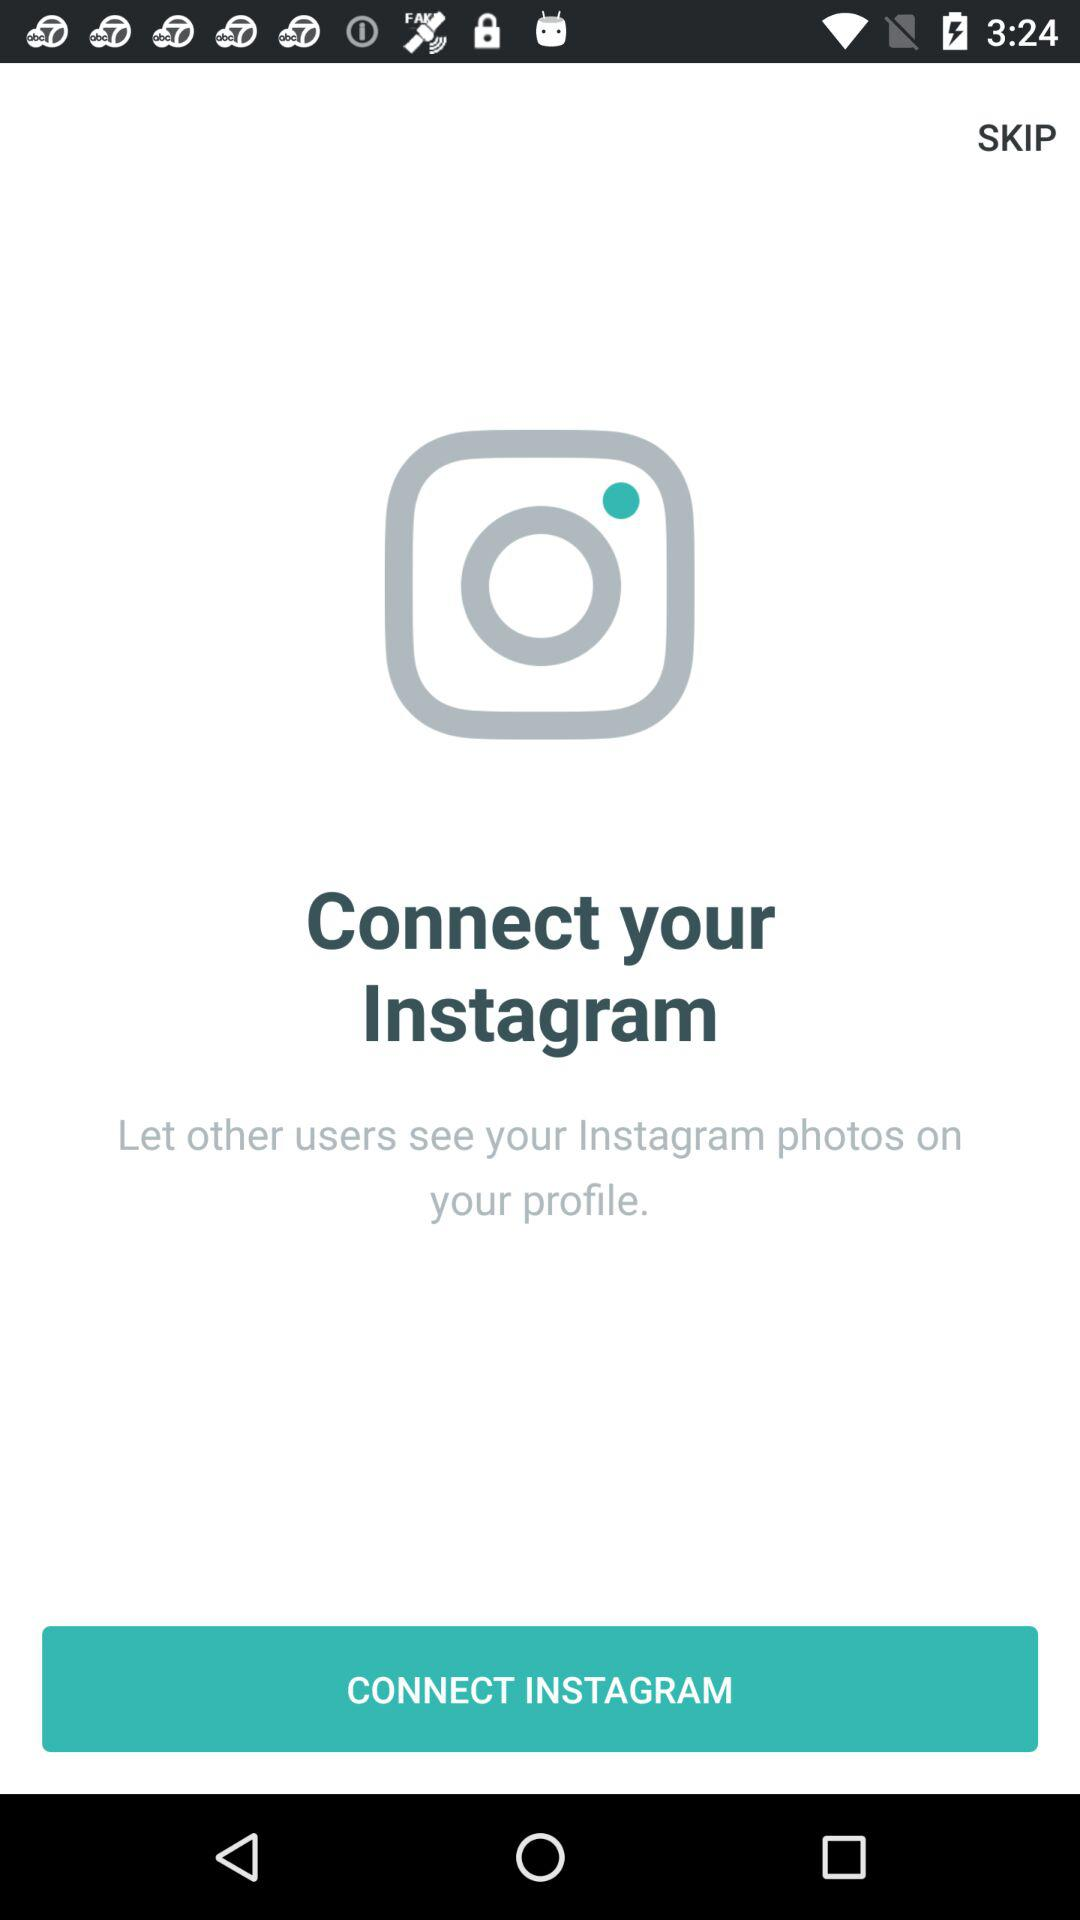What is the name of the application? The name of the application is "Instagram". 